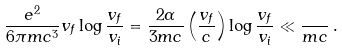Convert formula to latex. <formula><loc_0><loc_0><loc_500><loc_500>\frac { e ^ { 2 } } { 6 \pi m c ^ { 3 } } v _ { f } \log \frac { v _ { f } } { v _ { i } } = \frac { 2 \alpha } { 3 m c } \left ( \frac { v _ { f } } { c } \right ) \log \frac { v _ { f } } { v _ { i } } \ll \frac { } { m c } \, .</formula> 